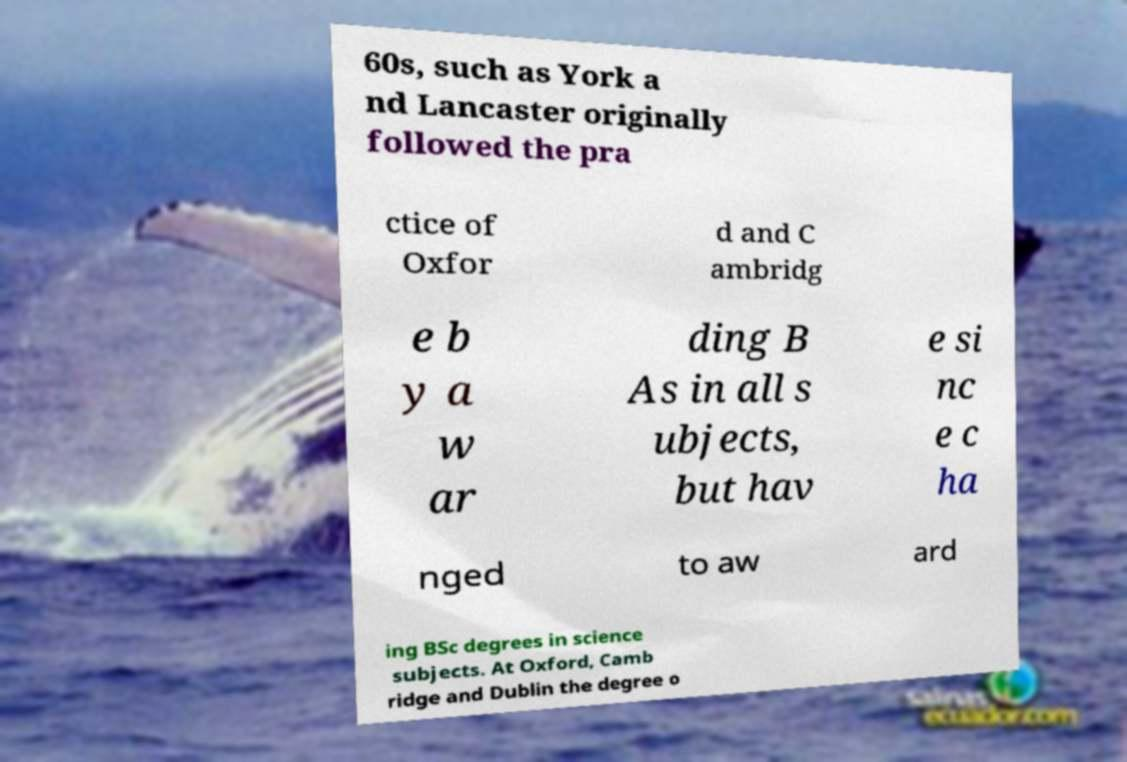Can you read and provide the text displayed in the image?This photo seems to have some interesting text. Can you extract and type it out for me? 60s, such as York a nd Lancaster originally followed the pra ctice of Oxfor d and C ambridg e b y a w ar ding B As in all s ubjects, but hav e si nc e c ha nged to aw ard ing BSc degrees in science subjects. At Oxford, Camb ridge and Dublin the degree o 